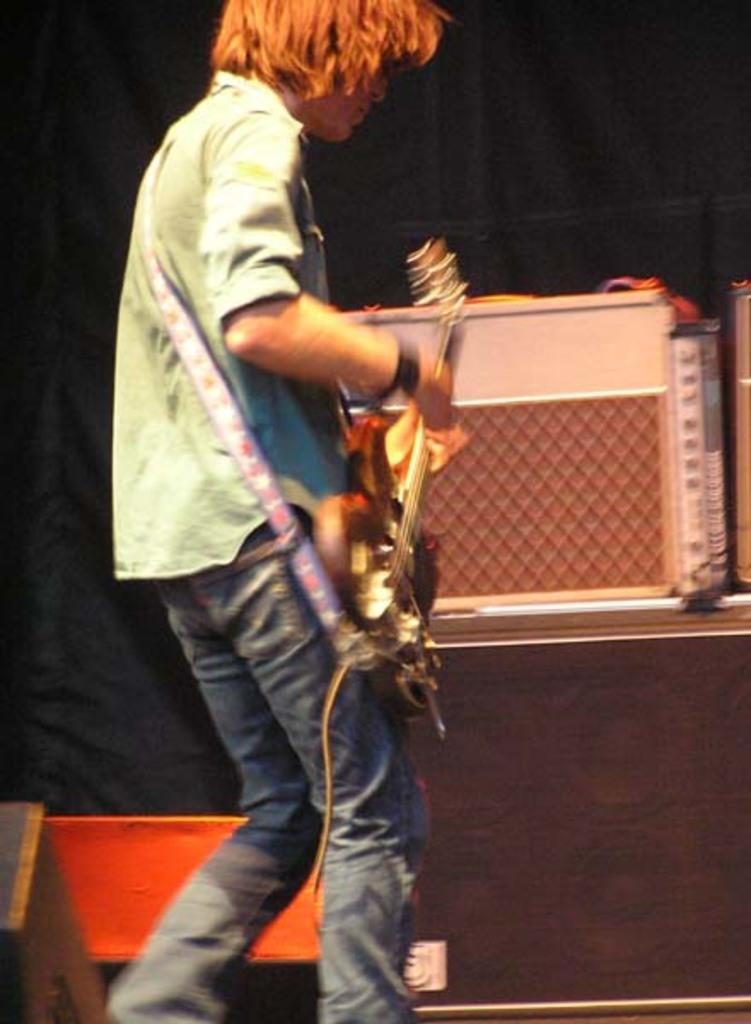What is the main subject of the image? The main subject of the image is a man. Where is the man located in the image? The man is standing on a stage. What is the man doing on the stage? The man is playing a guitar. What type of sweater is the man wearing in the image? There is no mention of a sweater in the image, so it cannot be determined what type of sweater the man might be wearing. 